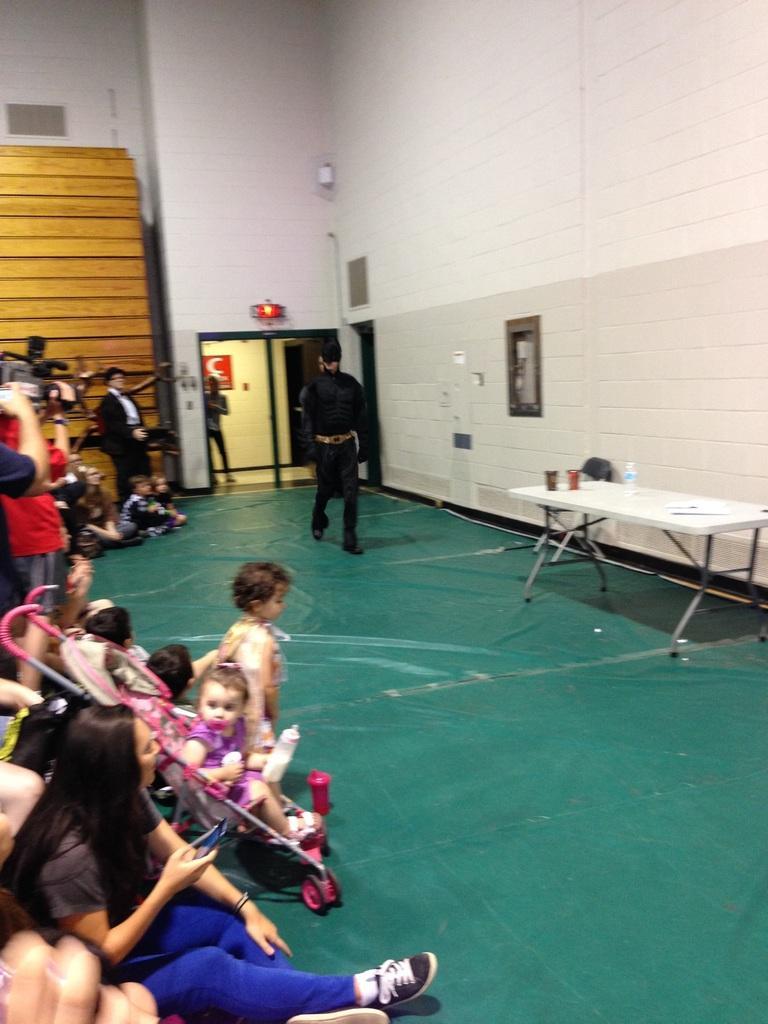Can you describe this image briefly? As we can see in the image there are few people here and there, wall, table and a door. Here there is a photo frame. On table there is a bottle and glass. On the left side there is a man holding camera. 